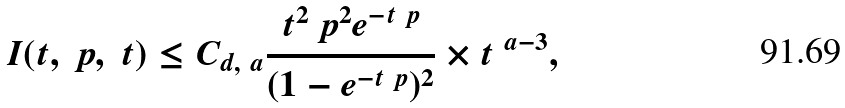<formula> <loc_0><loc_0><loc_500><loc_500>I ( t , \ p , \ t ) \leq C _ { d , \ a } \frac { t ^ { 2 } \ p ^ { 2 } e ^ { - t \ p } } { ( 1 - e ^ { - t \ p } ) ^ { 2 } } \times t ^ { \ a - 3 } ,</formula> 